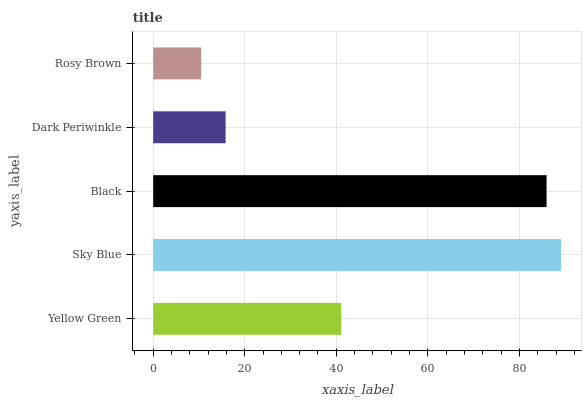Is Rosy Brown the minimum?
Answer yes or no. Yes. Is Sky Blue the maximum?
Answer yes or no. Yes. Is Black the minimum?
Answer yes or no. No. Is Black the maximum?
Answer yes or no. No. Is Sky Blue greater than Black?
Answer yes or no. Yes. Is Black less than Sky Blue?
Answer yes or no. Yes. Is Black greater than Sky Blue?
Answer yes or no. No. Is Sky Blue less than Black?
Answer yes or no. No. Is Yellow Green the high median?
Answer yes or no. Yes. Is Yellow Green the low median?
Answer yes or no. Yes. Is Dark Periwinkle the high median?
Answer yes or no. No. Is Dark Periwinkle the low median?
Answer yes or no. No. 